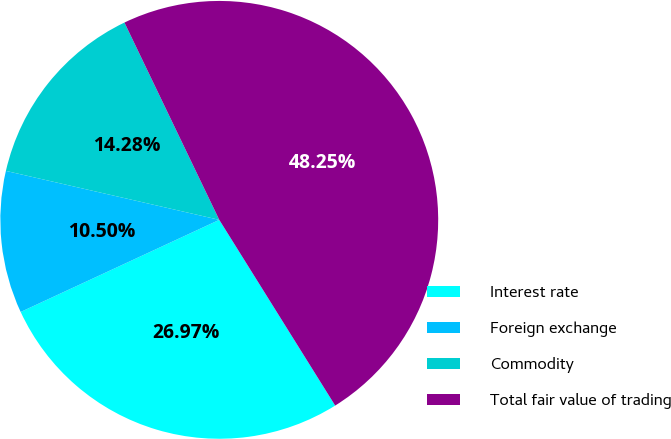Convert chart. <chart><loc_0><loc_0><loc_500><loc_500><pie_chart><fcel>Interest rate<fcel>Foreign exchange<fcel>Commodity<fcel>Total fair value of trading<nl><fcel>26.97%<fcel>10.5%<fcel>14.28%<fcel>48.25%<nl></chart> 